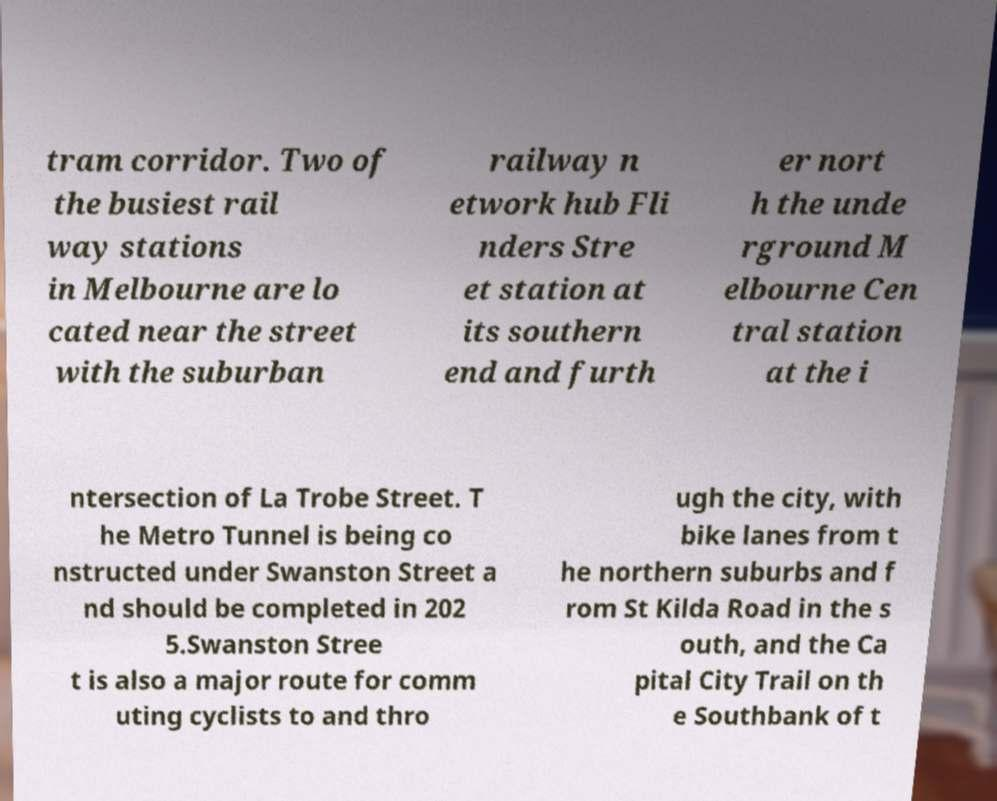What messages or text are displayed in this image? I need them in a readable, typed format. tram corridor. Two of the busiest rail way stations in Melbourne are lo cated near the street with the suburban railway n etwork hub Fli nders Stre et station at its southern end and furth er nort h the unde rground M elbourne Cen tral station at the i ntersection of La Trobe Street. T he Metro Tunnel is being co nstructed under Swanston Street a nd should be completed in 202 5.Swanston Stree t is also a major route for comm uting cyclists to and thro ugh the city, with bike lanes from t he northern suburbs and f rom St Kilda Road in the s outh, and the Ca pital City Trail on th e Southbank of t 